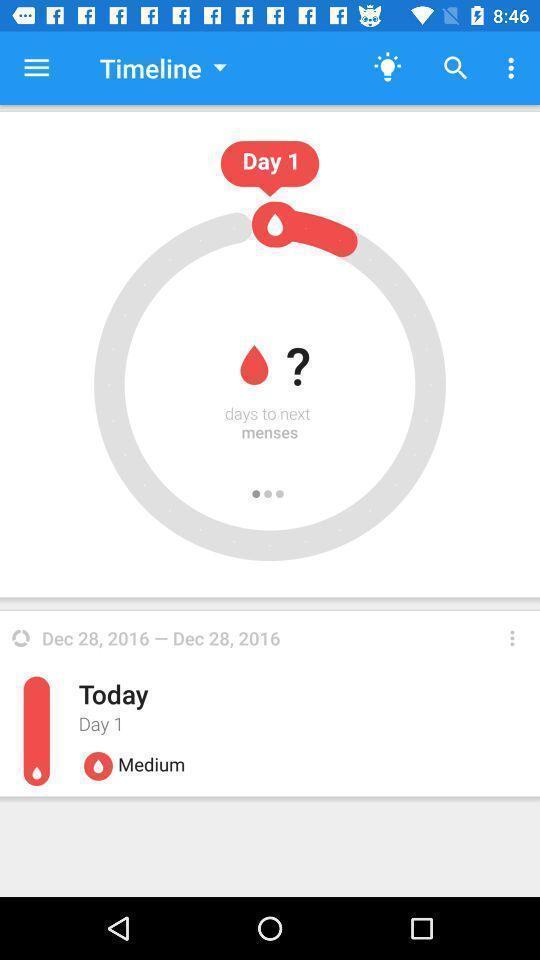Tell me what you see in this picture. Page displays the timeline option in the health care app. 